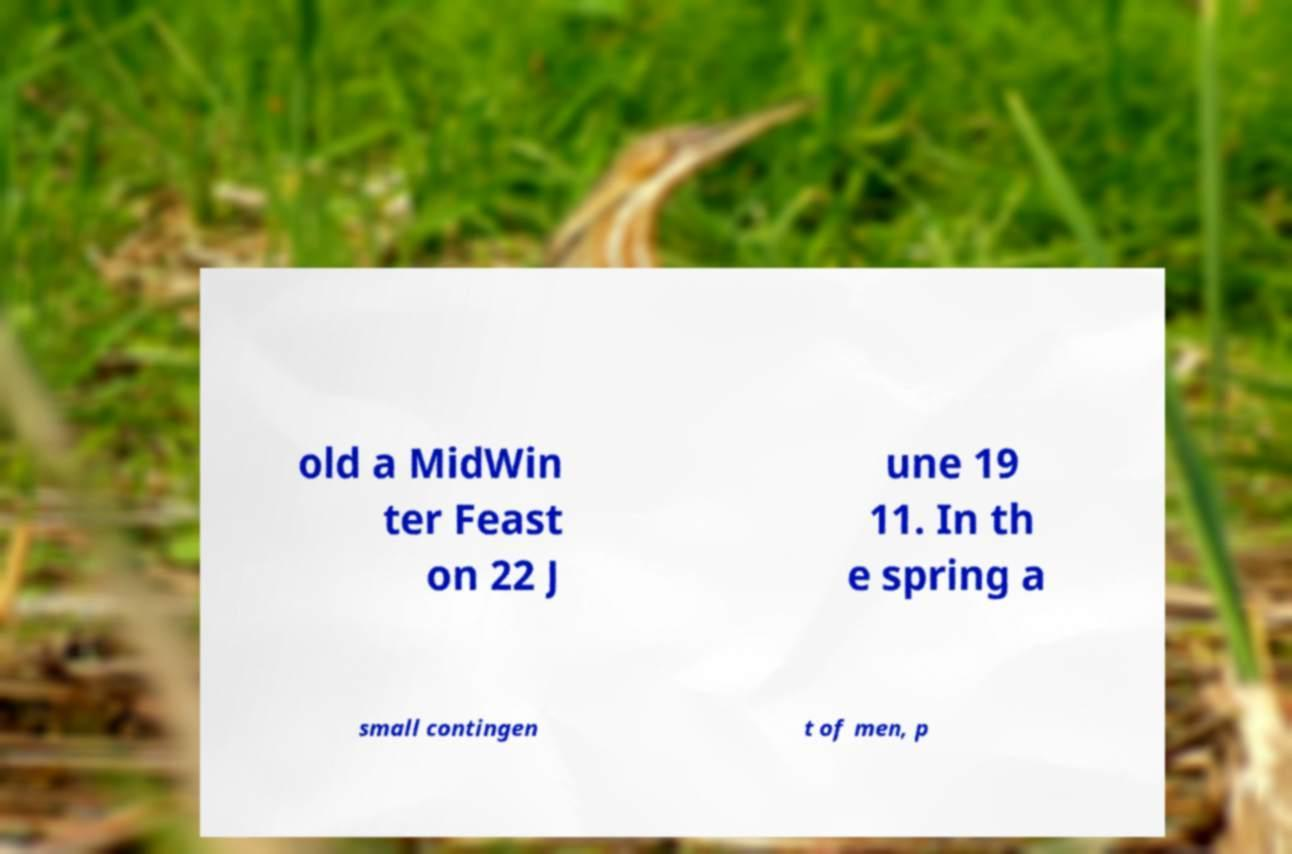Please identify and transcribe the text found in this image. old a MidWin ter Feast on 22 J une 19 11. In th e spring a small contingen t of men, p 